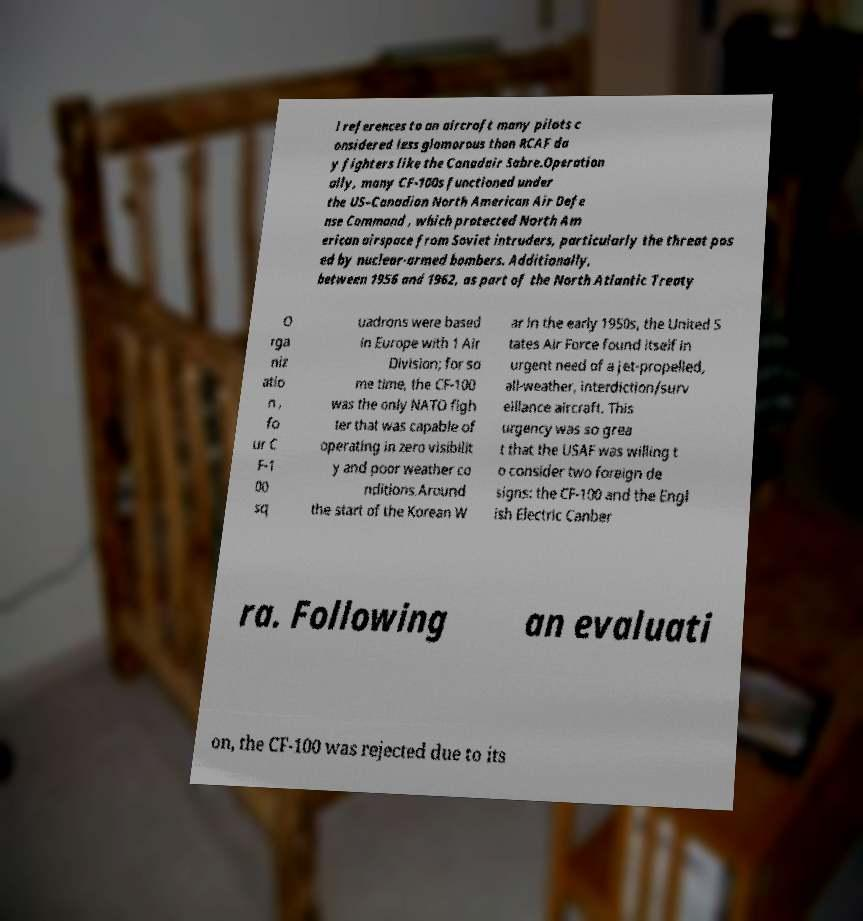Could you assist in decoding the text presented in this image and type it out clearly? l references to an aircraft many pilots c onsidered less glamorous than RCAF da y fighters like the Canadair Sabre.Operation ally, many CF-100s functioned under the US–Canadian North American Air Defe nse Command , which protected North Am erican airspace from Soviet intruders, particularly the threat pos ed by nuclear-armed bombers. Additionally, between 1956 and 1962, as part of the North Atlantic Treaty O rga niz atio n , fo ur C F-1 00 sq uadrons were based in Europe with 1 Air Division; for so me time, the CF-100 was the only NATO figh ter that was capable of operating in zero visibilit y and poor weather co nditions.Around the start of the Korean W ar in the early 1950s, the United S tates Air Force found itself in urgent need of a jet-propelled, all-weather, interdiction/surv eillance aircraft. This urgency was so grea t that the USAF was willing t o consider two foreign de signs: the CF-100 and the Engl ish Electric Canber ra. Following an evaluati on, the CF-100 was rejected due to its 